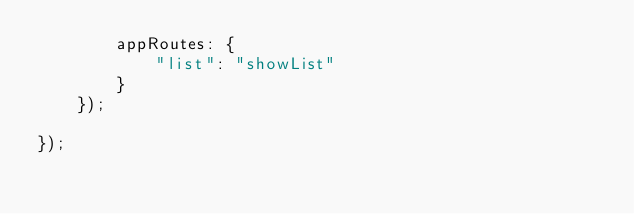Convert code to text. <code><loc_0><loc_0><loc_500><loc_500><_JavaScript_>        appRoutes: {
            "list": "showList"
        }
    });

});</code> 